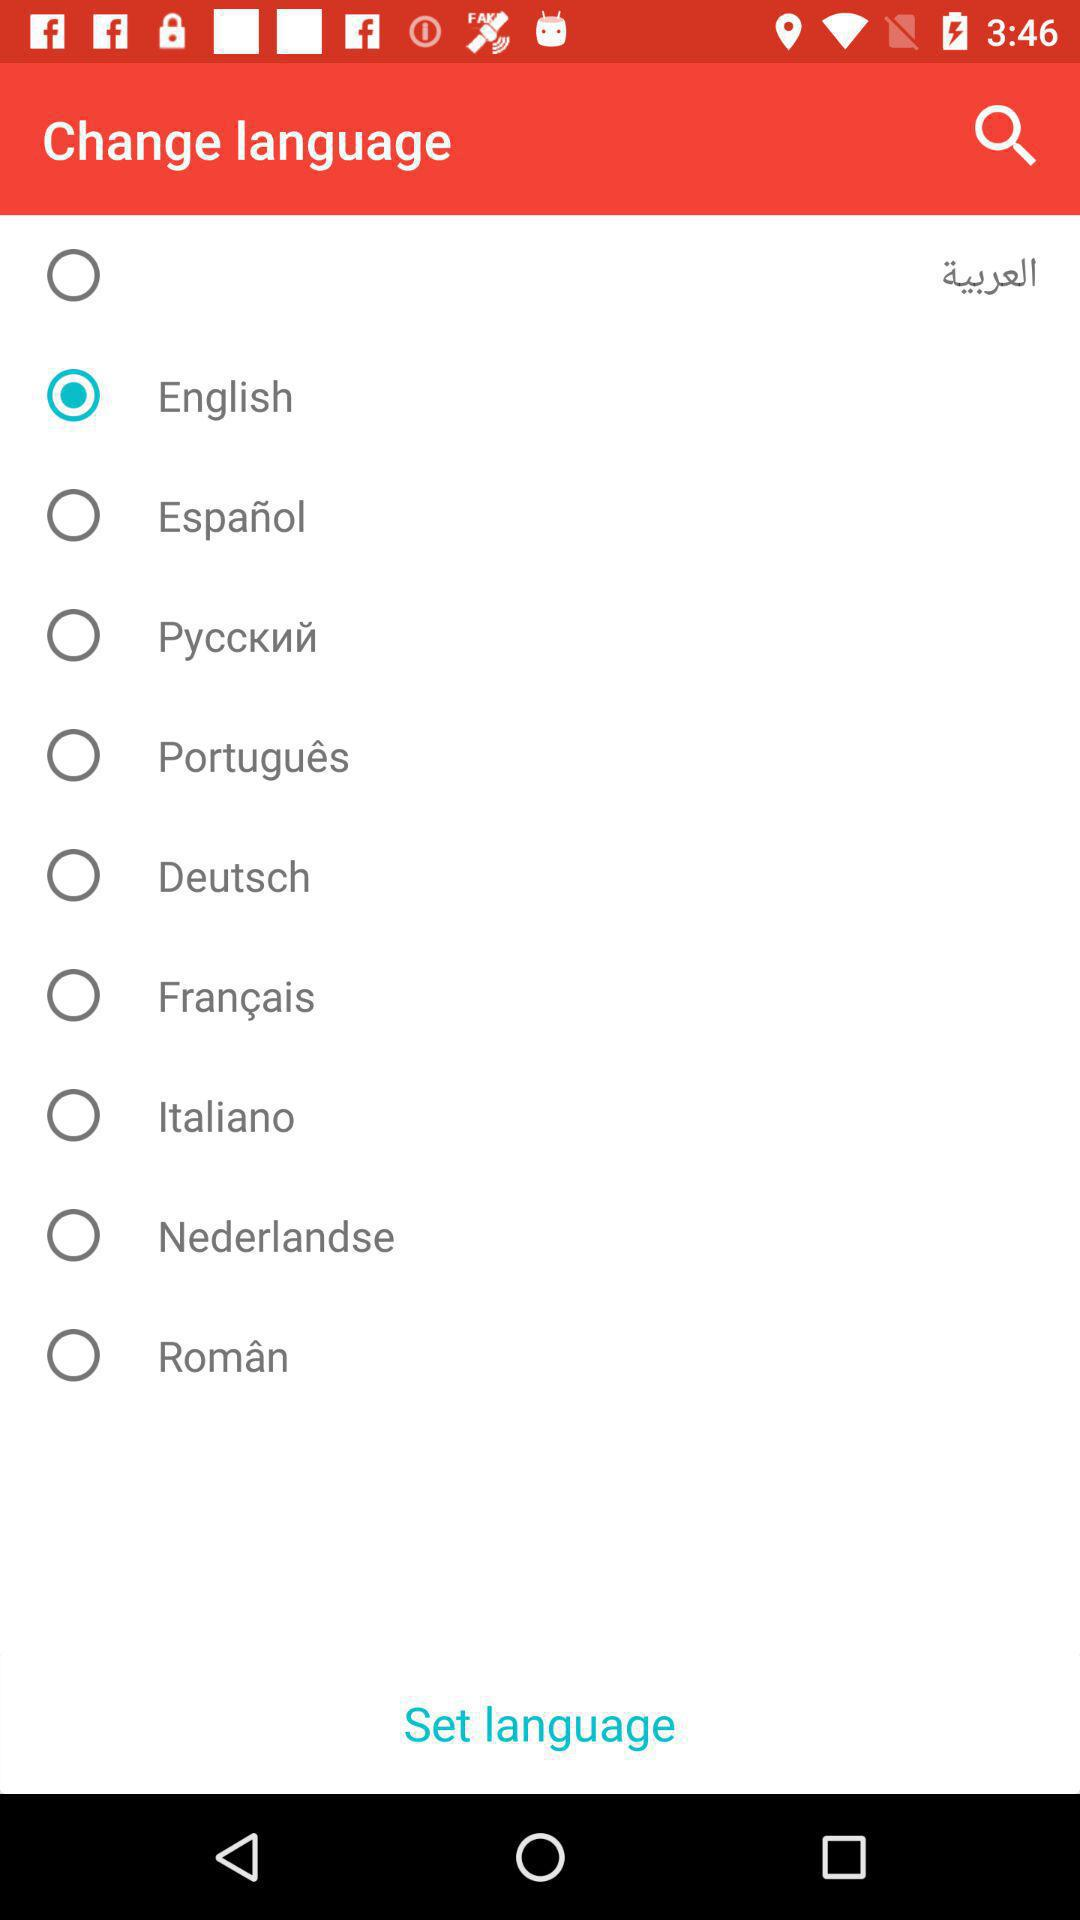How many languages are available to select from?
Answer the question using a single word or phrase. 10 